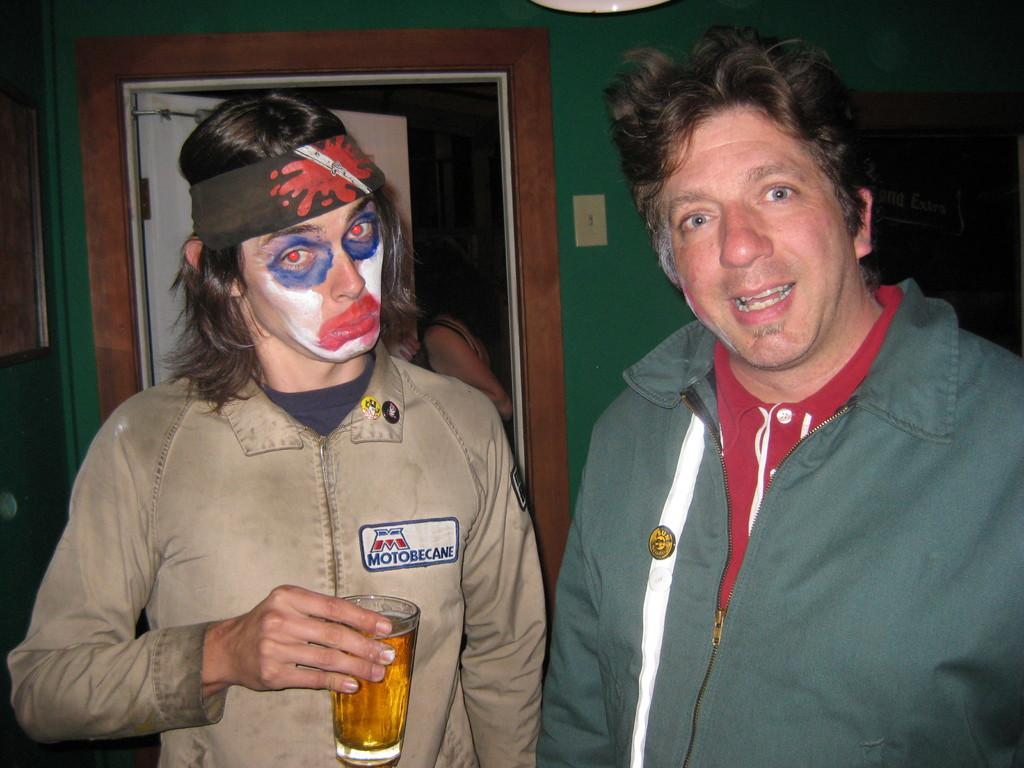How many people are in the image? There are people in the image, but the exact number is not specified. What is one person holding in the image? One person is holding a glass with liquid. What can be seen in the background of the image? There is a wall and a door in the background of the image. What type of lipstick is the kitten wearing in the image? There is no kitten present in the image, and therefore no lipstick or any other accessories can be observed on a kitten. 